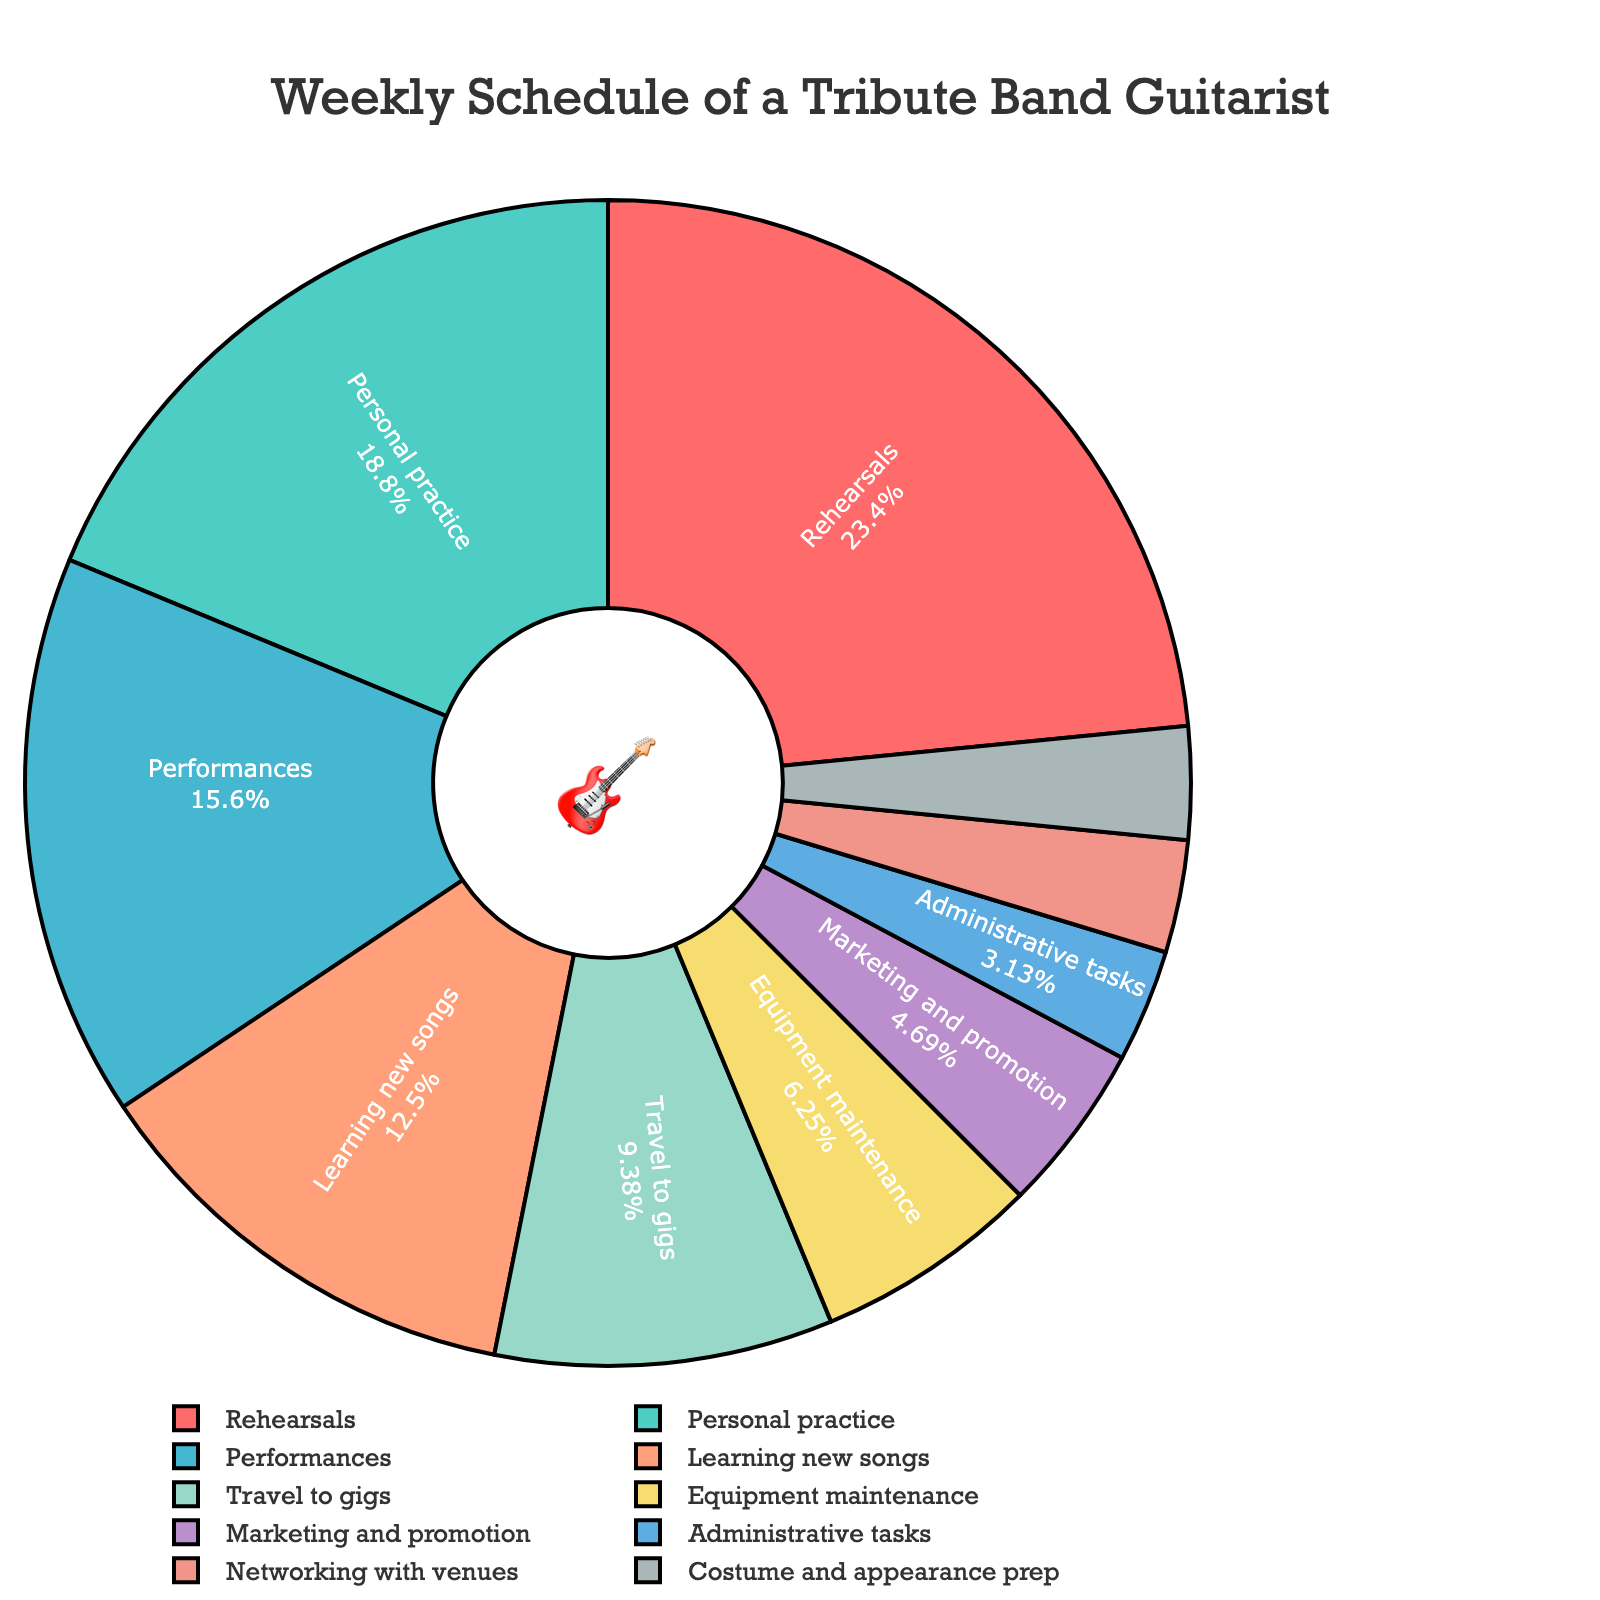what's the activity with the highest percentage of time allocation? To find the activity with the highest percentage, look for the largest segment in the pie chart. The largest segment corresponds to Rehearsals.
Answer: Rehearsals how much more time is spent on personal practice compared to marketing and promotion? First, find the hours spent on personal practice (12) and marketing and promotion (3). The difference is 12 - 3.
Answer: 9 hours what percentage of the week is spent on performances? The total weekly hours are the sum of all listed activities (64 hours). Performances take 10 hours, so the percentage is (10/64) * 100.
Answer: ~15.6% which two activities have the smallest time allocations? Identify the two smallest segments in the pie chart. Administrative tasks and Networking with venues each take 2 hours.
Answer: Administrative tasks and Networking with venues is more time spent on travel to gigs or on learning new songs? Compare the hours spent on travel to gigs (6) and learning new songs (8). Since 8 > 6.
Answer: Learning new songs what's the combined percentage of time spent on equipment maintenance, performances, and rehearsals? Find the total hours for these activities (4 + 10 + 15 = 29). Calculate the percentage: (29/64) * 100.
Answer: ~45.3% how does the time spent on costume and appearance prep compare to the time spent on administrative tasks? Both activities have the same time allocation of 2 hours each.
Answer: Equal what's the ratio of hours spent on personal practice to learning new songs? Find the ratio by dividing the hours spent on personal practice (12) by the hours spent on learning new songs (8).
Answer: 1.5:1 what color represents the time spent on travel to gigs? Identify the segment representing Travel to gigs and note its color. It is a shade of blue.
Answer: Blue how much less time is spent on networking with venues than on personal practice? Find the difference between the hours spent on personal practice (12) and networking with venues (2).
Answer: 10 hours 